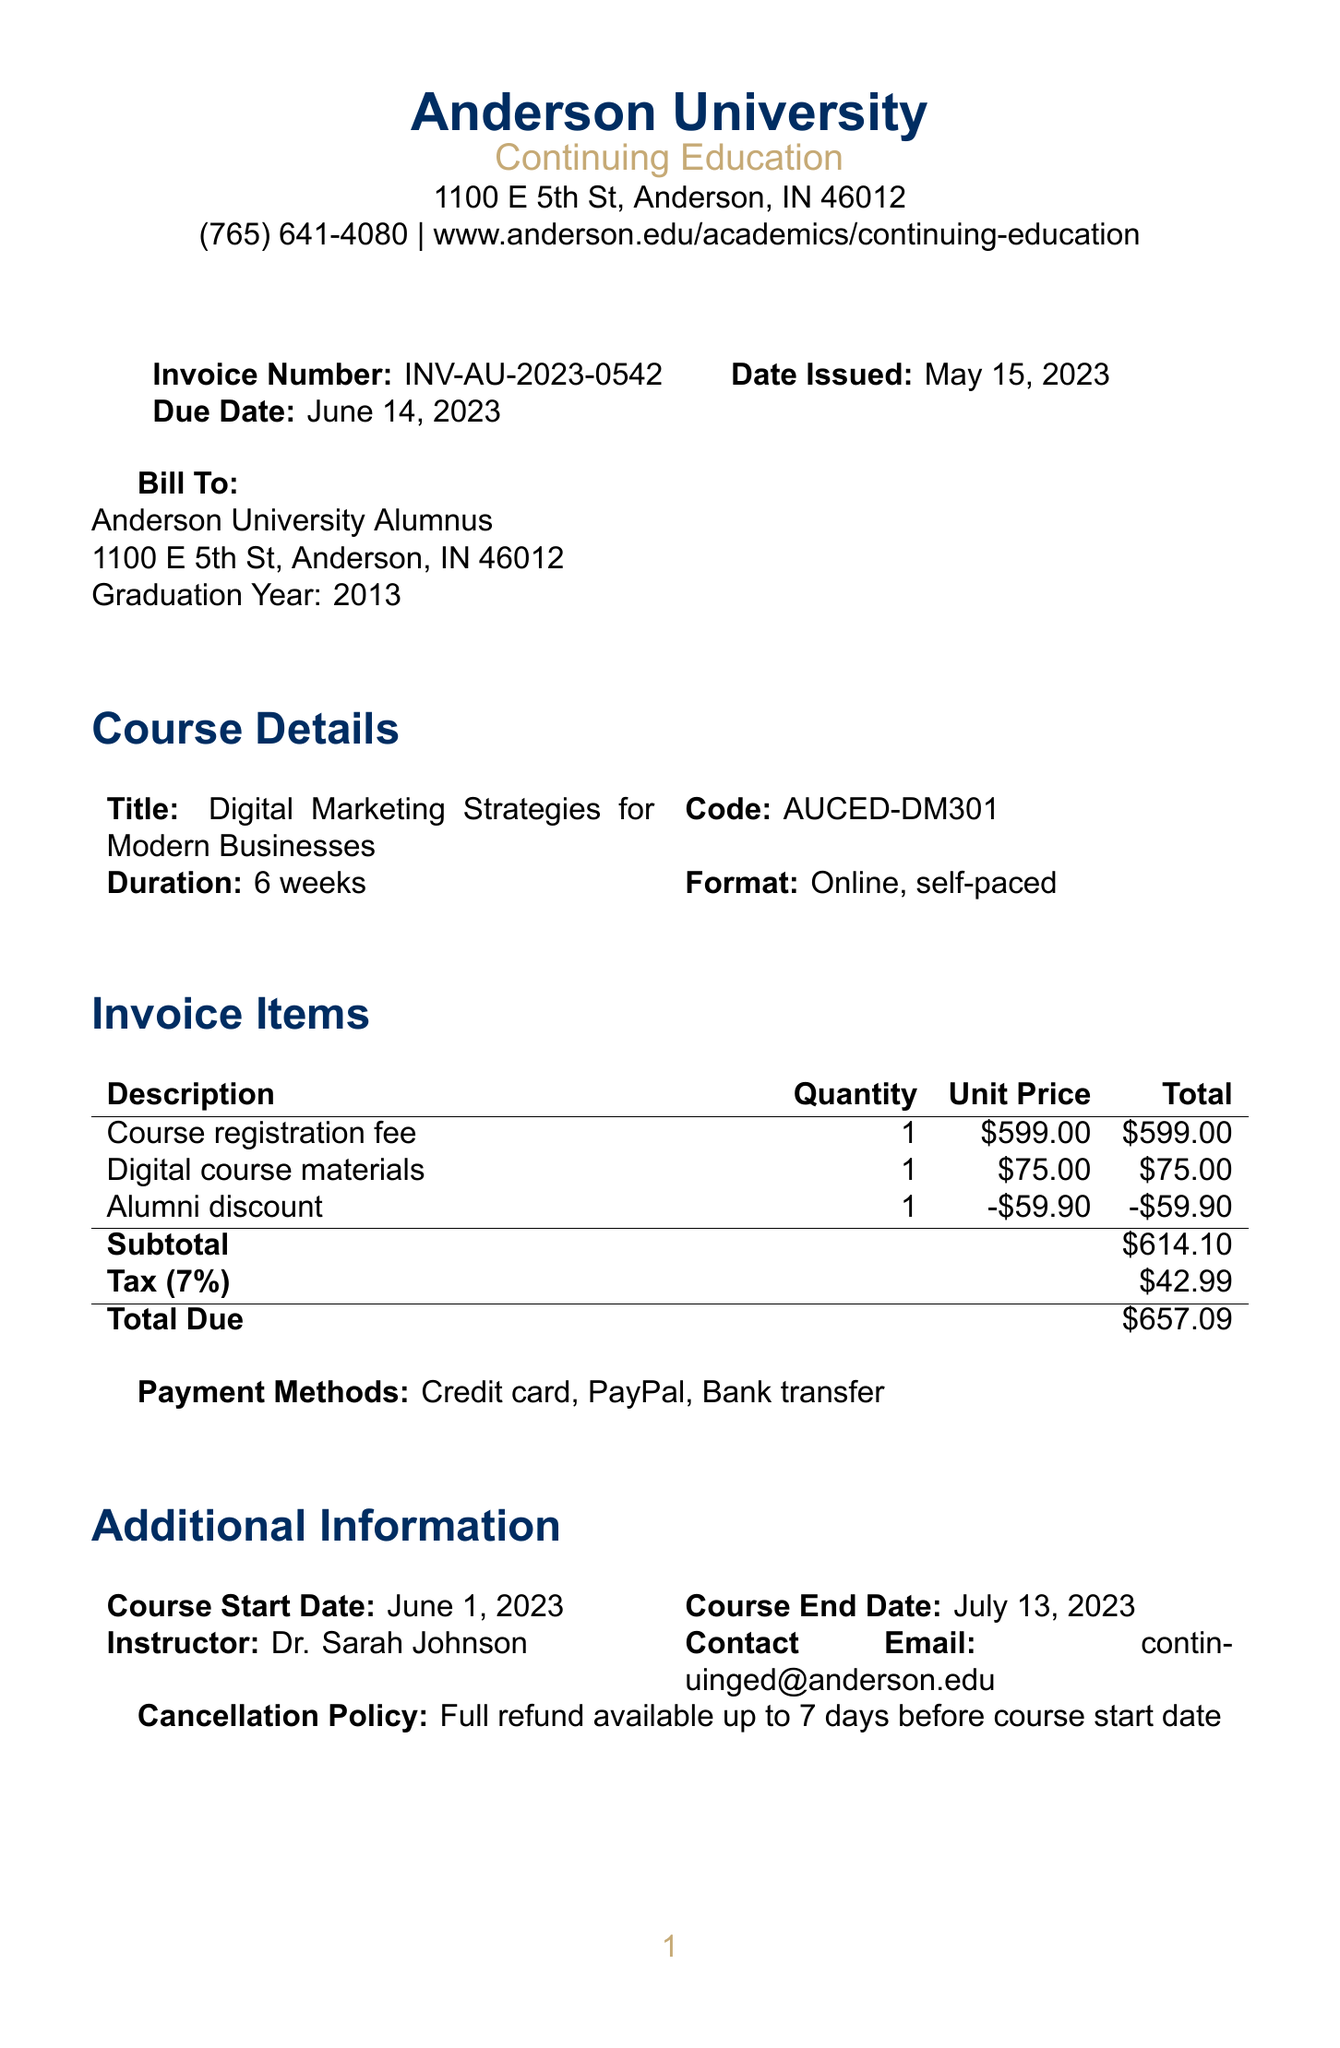What is the invoice number? The invoice number is specifically mentioned in the document as a unique identifier for this transaction.
Answer: INV-AU-2023-0542 When was the invoice issued? The date issued is clearly stated in the document, indicating when the invoice was created.
Answer: May 15, 2023 What is the total due amount? The total due amount represents the final cost, incorporating all fees, discounts, and taxes.
Answer: $657.09 What is the course title? The course title is provided in the document as the main subject of the professional development offering.
Answer: Digital Marketing Strategies for Modern Businesses Who is the instructor for the course? The instructor's name is listed in the document, identifying the person teaching the course.
Answer: Dr. Sarah Johnson What is the cancellation policy? The cancellation policy describes the conditions under which refunds can be requested and how long in advance they must be made.
Answer: Full refund available up to 7 days before course start date How long is the course duration? The document specifies the length of the course in weeks, providing a clear expectation for participants.
Answer: 6 weeks What payment methods are available? The payment methods listed indicate how participants can complete their payment for the invoice.
Answer: Credit card, PayPal, Bank transfer What is the graduation year of the alumnus? The graduation year signifies when the alumnus completed their studies at the institution, as recorded in the document.
Answer: 2013 